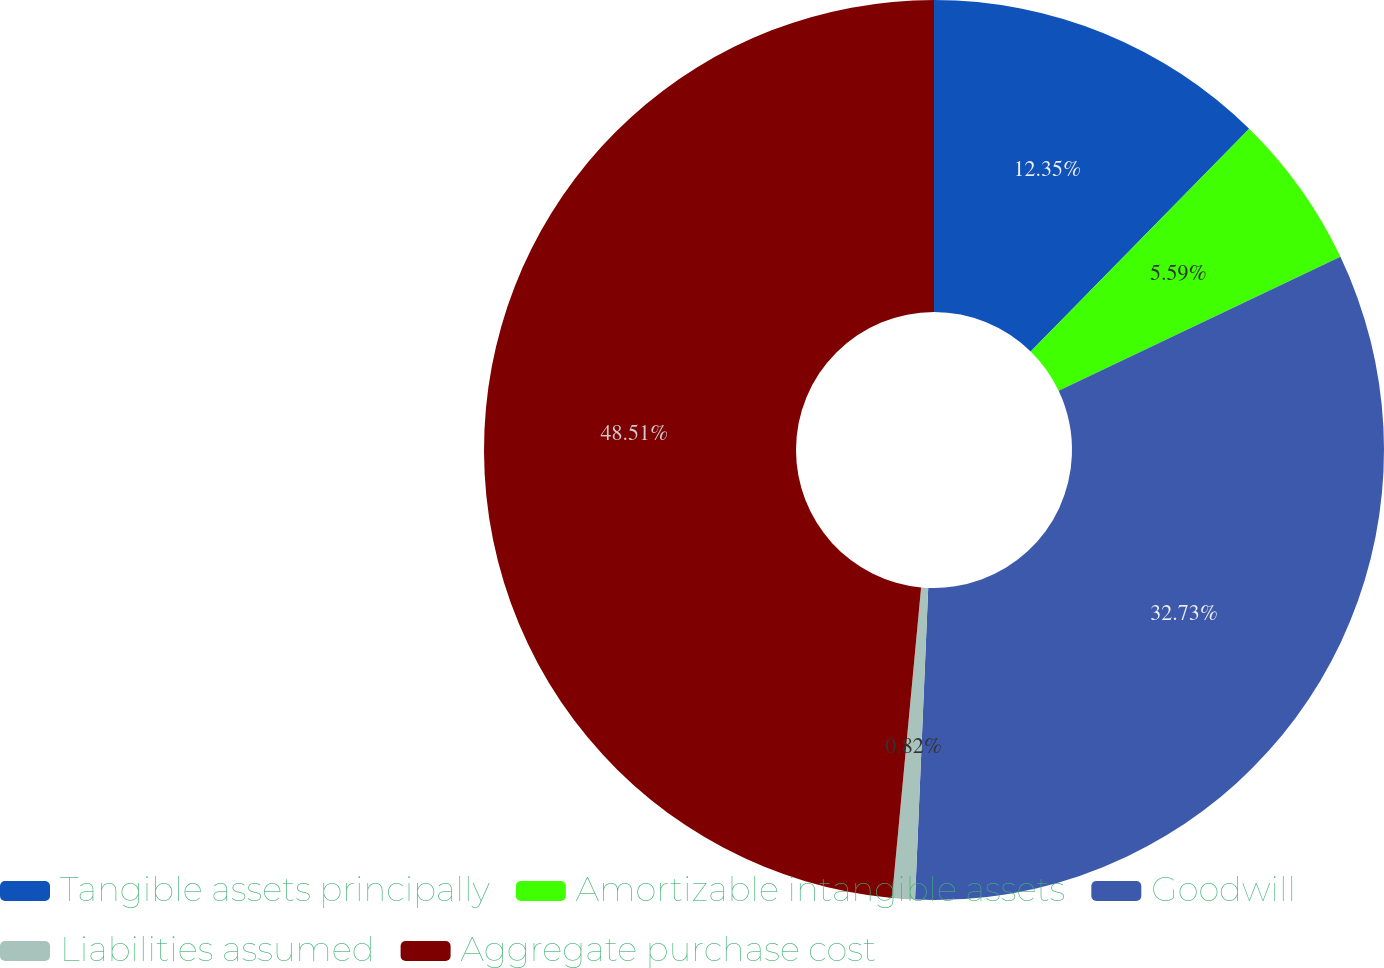<chart> <loc_0><loc_0><loc_500><loc_500><pie_chart><fcel>Tangible assets principally<fcel>Amortizable intangible assets<fcel>Goodwill<fcel>Liabilities assumed<fcel>Aggregate purchase cost<nl><fcel>12.35%<fcel>5.59%<fcel>32.73%<fcel>0.82%<fcel>48.51%<nl></chart> 